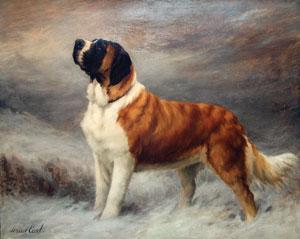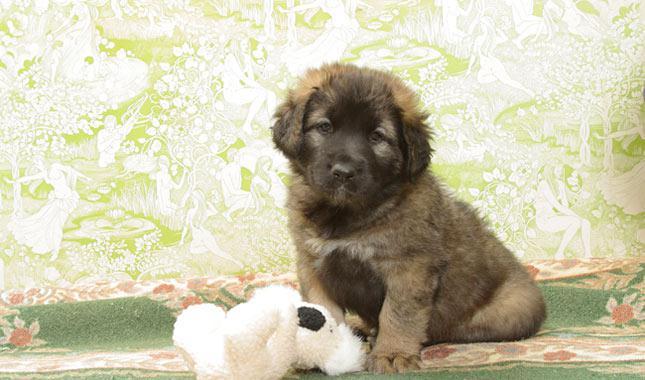The first image is the image on the left, the second image is the image on the right. Analyze the images presented: Is the assertion "One image shows a puppy and the other shows an adult dog." valid? Answer yes or no. Yes. 